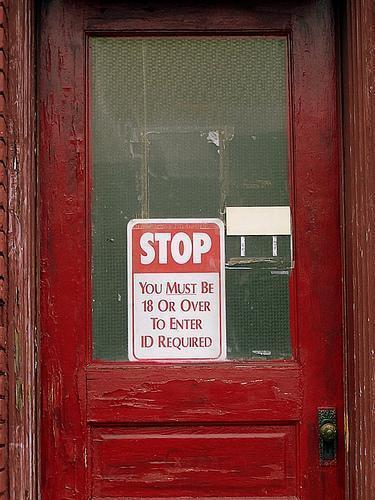How many signs are in the picture?
Give a very brief answer. 1. 